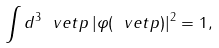<formula> <loc_0><loc_0><loc_500><loc_500>\int d ^ { 3 } \ v e t { p } \, | \varphi ( \ v e t { p } ) | ^ { 2 } = 1 ,</formula> 